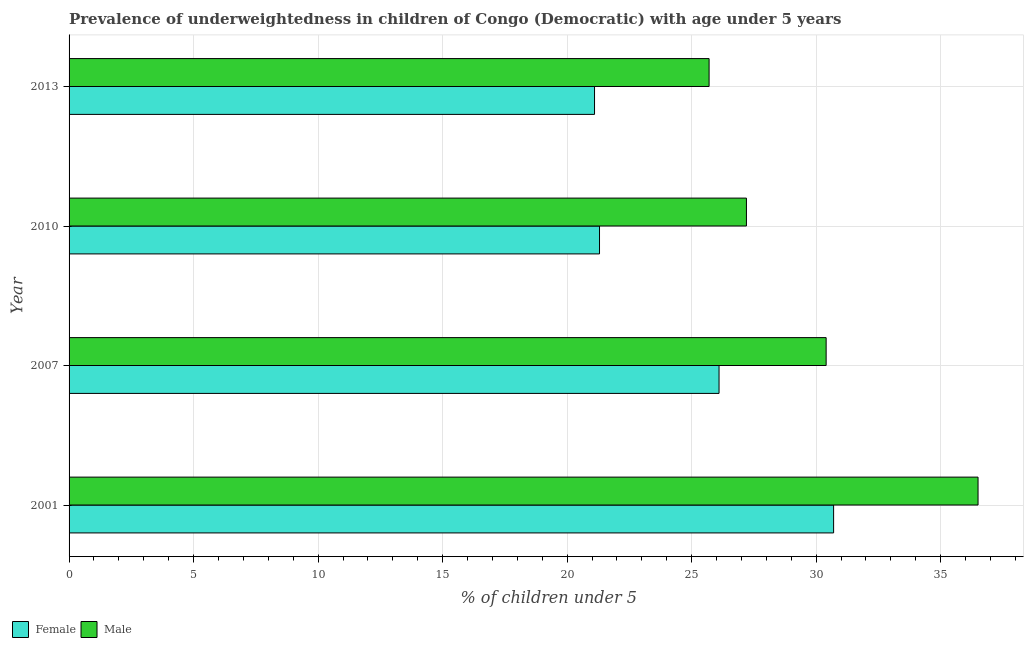How many groups of bars are there?
Provide a succinct answer. 4. Are the number of bars on each tick of the Y-axis equal?
Offer a terse response. Yes. How many bars are there on the 1st tick from the bottom?
Keep it short and to the point. 2. What is the percentage of underweighted male children in 2013?
Give a very brief answer. 25.7. Across all years, what is the maximum percentage of underweighted male children?
Offer a very short reply. 36.5. Across all years, what is the minimum percentage of underweighted female children?
Keep it short and to the point. 21.1. What is the total percentage of underweighted male children in the graph?
Offer a terse response. 119.8. What is the difference between the percentage of underweighted male children in 2007 and the percentage of underweighted female children in 2001?
Ensure brevity in your answer.  -0.3. What is the average percentage of underweighted female children per year?
Offer a terse response. 24.8. In the year 2001, what is the difference between the percentage of underweighted male children and percentage of underweighted female children?
Your answer should be very brief. 5.8. What is the ratio of the percentage of underweighted female children in 2001 to that in 2013?
Your response must be concise. 1.46. What is the difference between the highest and the second highest percentage of underweighted male children?
Your answer should be compact. 6.1. What is the difference between the highest and the lowest percentage of underweighted male children?
Make the answer very short. 10.8. In how many years, is the percentage of underweighted male children greater than the average percentage of underweighted male children taken over all years?
Make the answer very short. 2. What does the 2nd bar from the bottom in 2010 represents?
Give a very brief answer. Male. How many bars are there?
Make the answer very short. 8. Are all the bars in the graph horizontal?
Keep it short and to the point. Yes. How many years are there in the graph?
Your answer should be compact. 4. What is the difference between two consecutive major ticks on the X-axis?
Your answer should be compact. 5. Where does the legend appear in the graph?
Ensure brevity in your answer.  Bottom left. What is the title of the graph?
Ensure brevity in your answer.  Prevalence of underweightedness in children of Congo (Democratic) with age under 5 years. Does "Arms exports" appear as one of the legend labels in the graph?
Make the answer very short. No. What is the label or title of the X-axis?
Offer a very short reply.  % of children under 5. What is the  % of children under 5 in Female in 2001?
Provide a succinct answer. 30.7. What is the  % of children under 5 in Male in 2001?
Make the answer very short. 36.5. What is the  % of children under 5 in Female in 2007?
Offer a very short reply. 26.1. What is the  % of children under 5 of Male in 2007?
Offer a terse response. 30.4. What is the  % of children under 5 of Female in 2010?
Ensure brevity in your answer.  21.3. What is the  % of children under 5 in Male in 2010?
Provide a short and direct response. 27.2. What is the  % of children under 5 of Female in 2013?
Your response must be concise. 21.1. What is the  % of children under 5 in Male in 2013?
Keep it short and to the point. 25.7. Across all years, what is the maximum  % of children under 5 in Female?
Keep it short and to the point. 30.7. Across all years, what is the maximum  % of children under 5 of Male?
Your response must be concise. 36.5. Across all years, what is the minimum  % of children under 5 of Female?
Give a very brief answer. 21.1. Across all years, what is the minimum  % of children under 5 of Male?
Your response must be concise. 25.7. What is the total  % of children under 5 of Female in the graph?
Make the answer very short. 99.2. What is the total  % of children under 5 in Male in the graph?
Keep it short and to the point. 119.8. What is the difference between the  % of children under 5 in Female in 2001 and that in 2007?
Make the answer very short. 4.6. What is the difference between the  % of children under 5 in Male in 2001 and that in 2007?
Provide a short and direct response. 6.1. What is the difference between the  % of children under 5 of Female in 2001 and that in 2010?
Offer a very short reply. 9.4. What is the difference between the  % of children under 5 in Male in 2001 and that in 2010?
Your response must be concise. 9.3. What is the difference between the  % of children under 5 in Female in 2001 and that in 2013?
Ensure brevity in your answer.  9.6. What is the difference between the  % of children under 5 in Female in 2007 and that in 2010?
Offer a terse response. 4.8. What is the difference between the  % of children under 5 in Male in 2007 and that in 2010?
Offer a terse response. 3.2. What is the difference between the  % of children under 5 of Female in 2007 and that in 2013?
Provide a succinct answer. 5. What is the difference between the  % of children under 5 in Female in 2010 and that in 2013?
Provide a short and direct response. 0.2. What is the difference between the  % of children under 5 in Female in 2007 and the  % of children under 5 in Male in 2010?
Make the answer very short. -1.1. What is the difference between the  % of children under 5 in Female in 2010 and the  % of children under 5 in Male in 2013?
Give a very brief answer. -4.4. What is the average  % of children under 5 of Female per year?
Keep it short and to the point. 24.8. What is the average  % of children under 5 of Male per year?
Your answer should be compact. 29.95. In the year 2001, what is the difference between the  % of children under 5 in Female and  % of children under 5 in Male?
Your answer should be very brief. -5.8. In the year 2007, what is the difference between the  % of children under 5 of Female and  % of children under 5 of Male?
Provide a short and direct response. -4.3. In the year 2013, what is the difference between the  % of children under 5 of Female and  % of children under 5 of Male?
Keep it short and to the point. -4.6. What is the ratio of the  % of children under 5 in Female in 2001 to that in 2007?
Your answer should be very brief. 1.18. What is the ratio of the  % of children under 5 of Male in 2001 to that in 2007?
Your answer should be compact. 1.2. What is the ratio of the  % of children under 5 of Female in 2001 to that in 2010?
Your response must be concise. 1.44. What is the ratio of the  % of children under 5 in Male in 2001 to that in 2010?
Provide a short and direct response. 1.34. What is the ratio of the  % of children under 5 in Female in 2001 to that in 2013?
Your response must be concise. 1.46. What is the ratio of the  % of children under 5 of Male in 2001 to that in 2013?
Ensure brevity in your answer.  1.42. What is the ratio of the  % of children under 5 in Female in 2007 to that in 2010?
Your response must be concise. 1.23. What is the ratio of the  % of children under 5 of Male in 2007 to that in 2010?
Give a very brief answer. 1.12. What is the ratio of the  % of children under 5 in Female in 2007 to that in 2013?
Ensure brevity in your answer.  1.24. What is the ratio of the  % of children under 5 of Male in 2007 to that in 2013?
Provide a succinct answer. 1.18. What is the ratio of the  % of children under 5 in Female in 2010 to that in 2013?
Your answer should be compact. 1.01. What is the ratio of the  % of children under 5 in Male in 2010 to that in 2013?
Your response must be concise. 1.06. What is the difference between the highest and the second highest  % of children under 5 in Male?
Your response must be concise. 6.1. What is the difference between the highest and the lowest  % of children under 5 in Female?
Your answer should be compact. 9.6. What is the difference between the highest and the lowest  % of children under 5 in Male?
Provide a short and direct response. 10.8. 